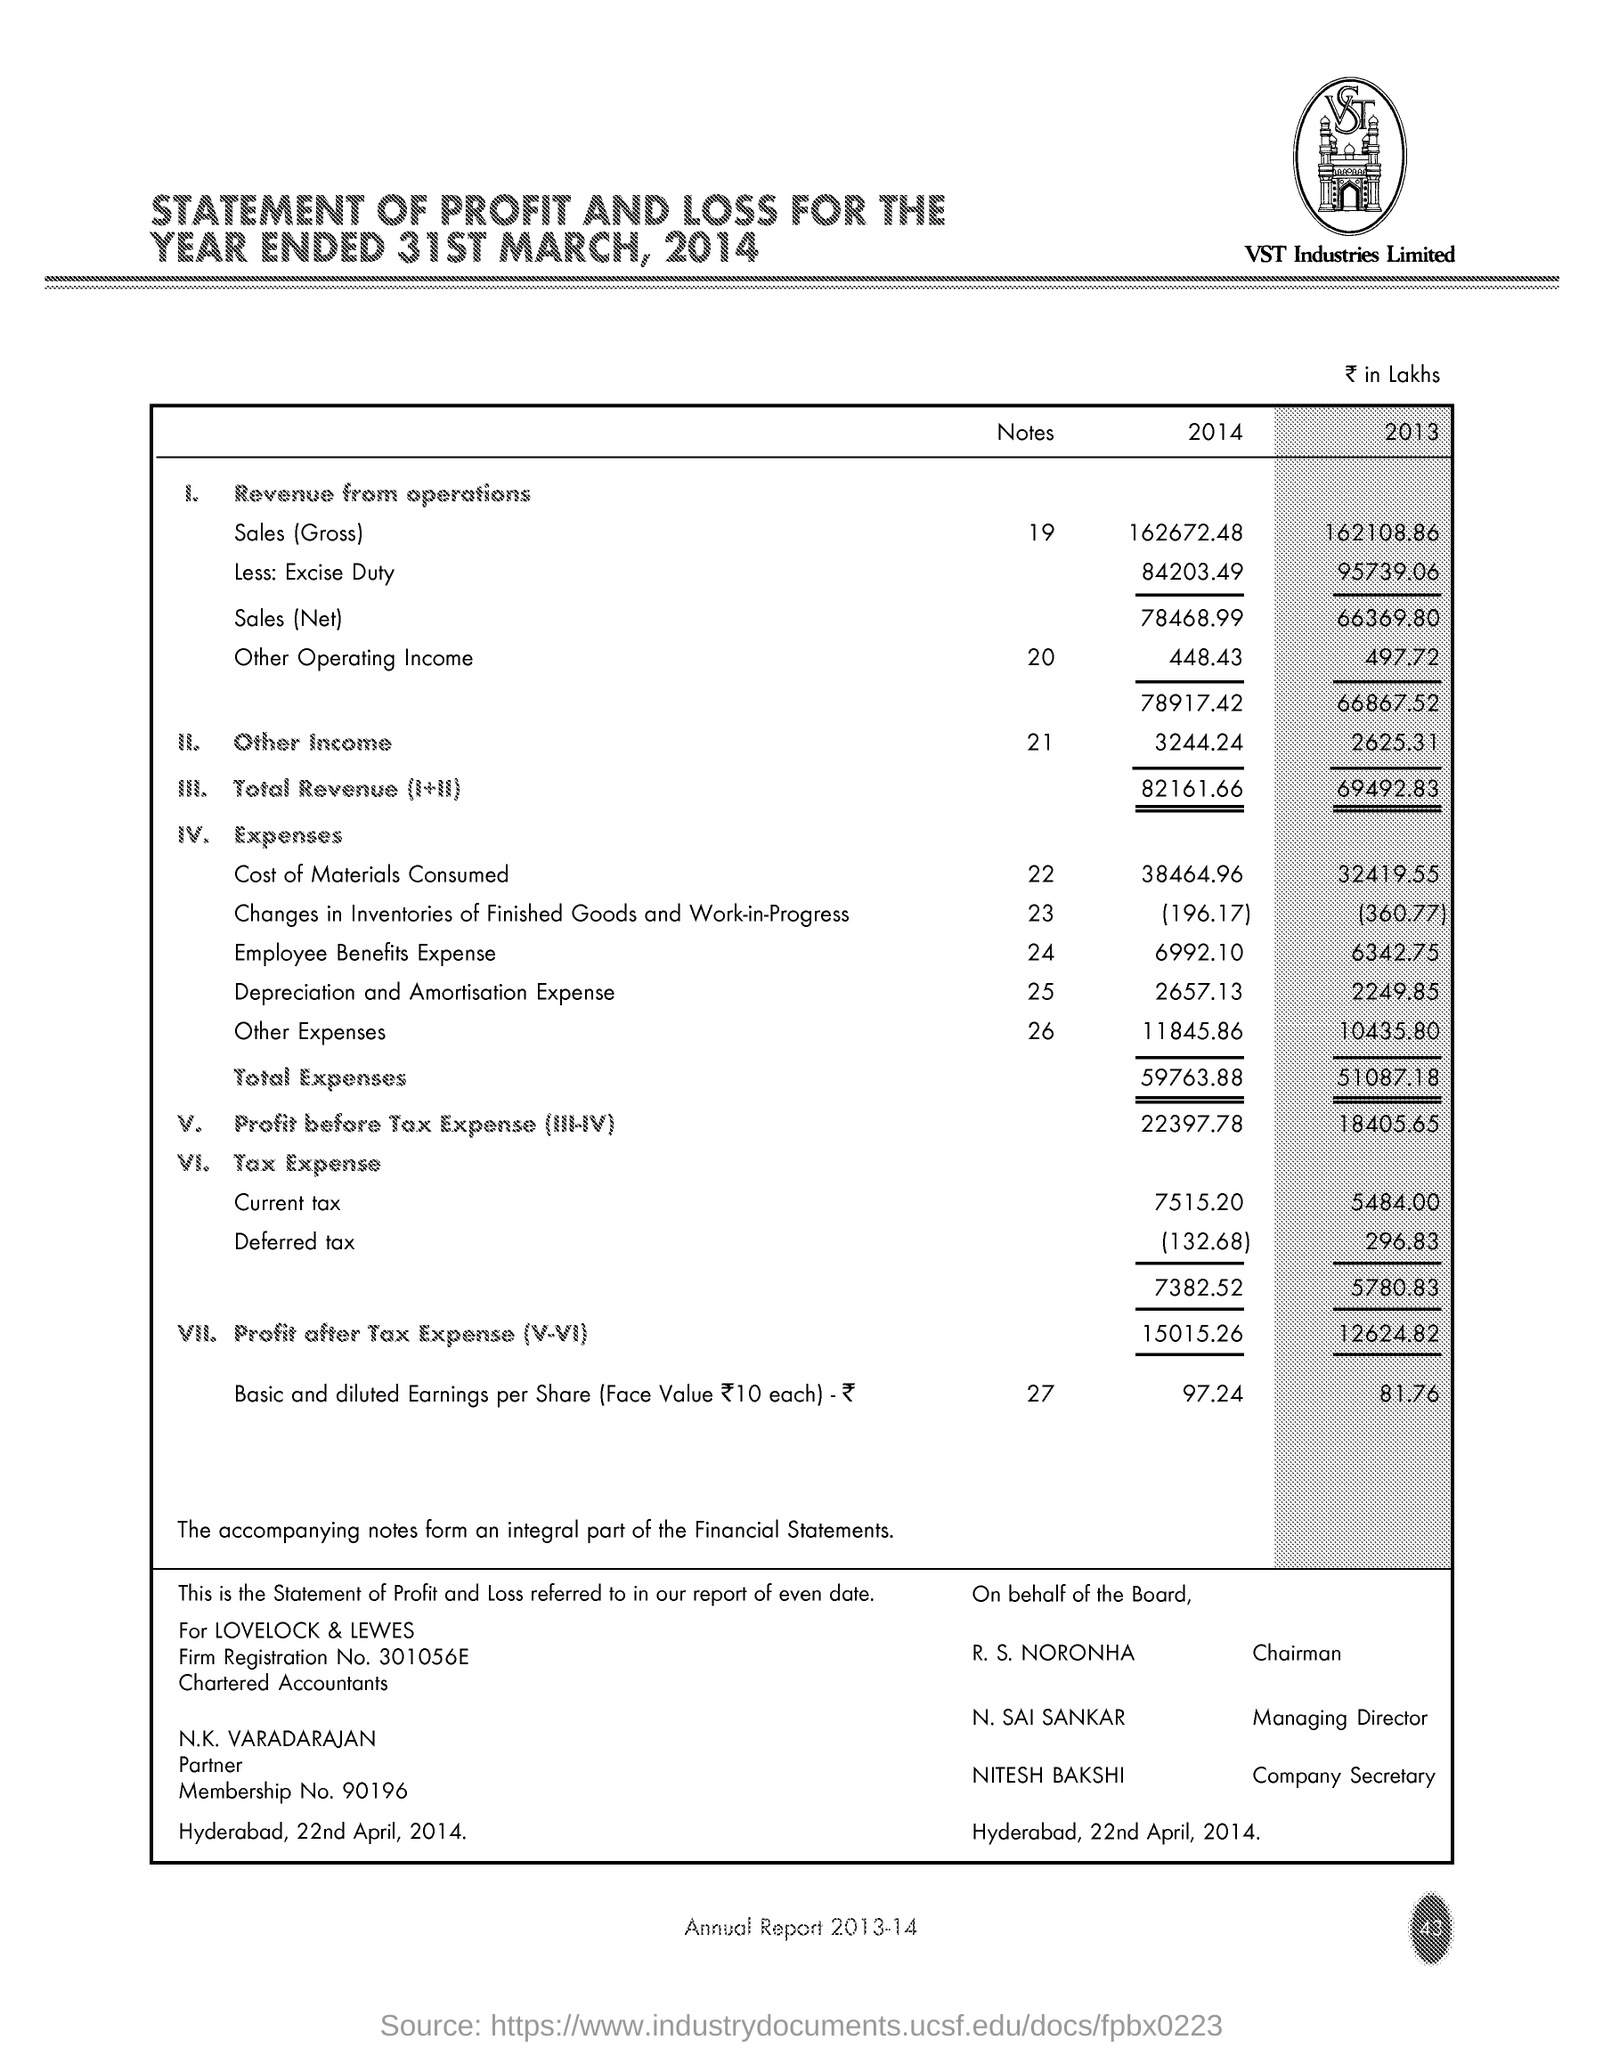Outline some significant characteristics in this image. The cost of materials consumed for the year 2013 was 32,419.55. The total revenue for the year 2014 was 82,161.66. The managing director is N. Sai Sankar. 